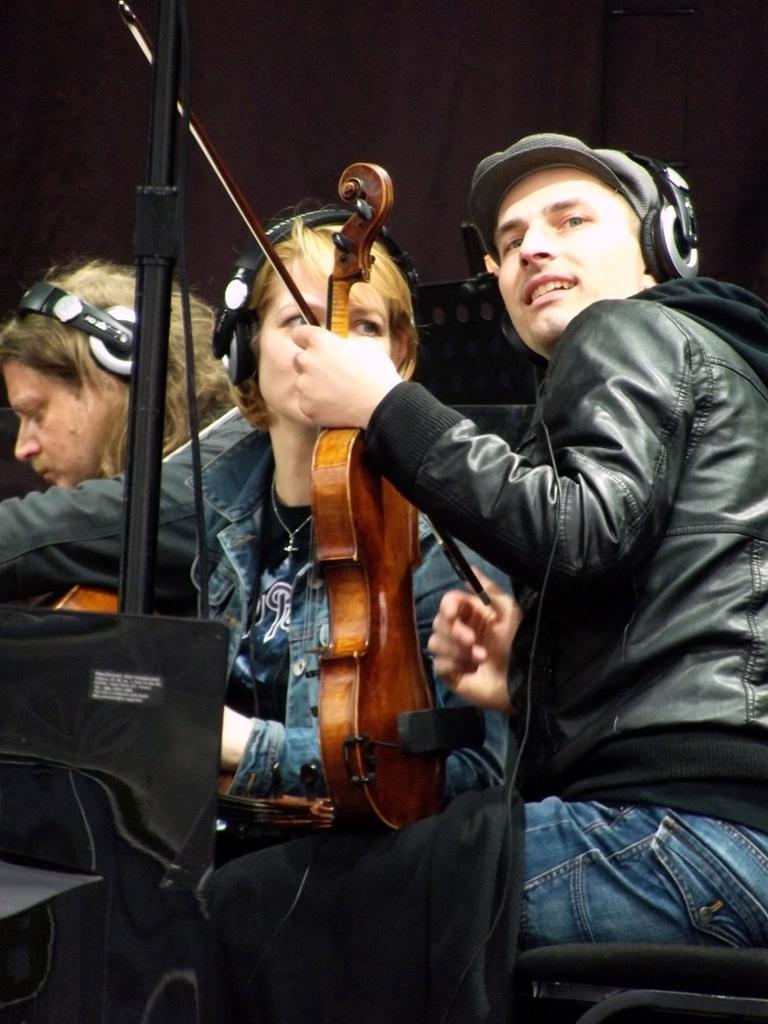Describe this image in one or two sentences. In the picture we can see three persons holding guitar and wearing headset,in front of them there was stand and cables. 